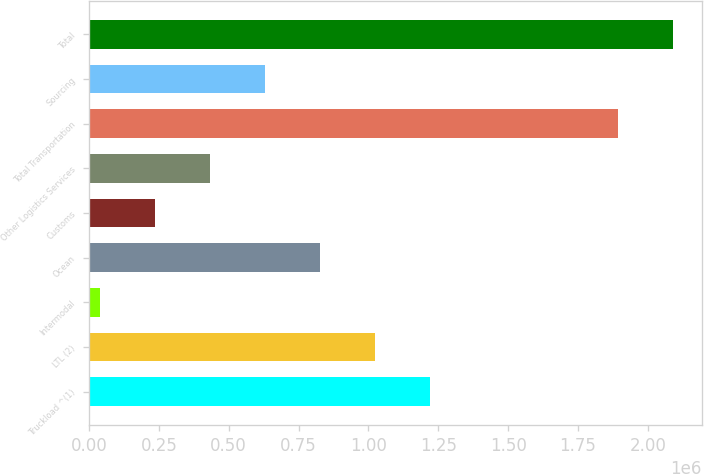<chart> <loc_0><loc_0><loc_500><loc_500><bar_chart><fcel>Truckload ^(1)<fcel>LTL (2)<fcel>Intermodal<fcel>Ocean<fcel>Customs<fcel>Other Logistics Services<fcel>Total Transportation<fcel>Sourcing<fcel>Total<nl><fcel>1.22084e+06<fcel>1.02414e+06<fcel>40631<fcel>827439<fcel>237333<fcel>434035<fcel>1.89211e+06<fcel>630737<fcel>2.08881e+06<nl></chart> 